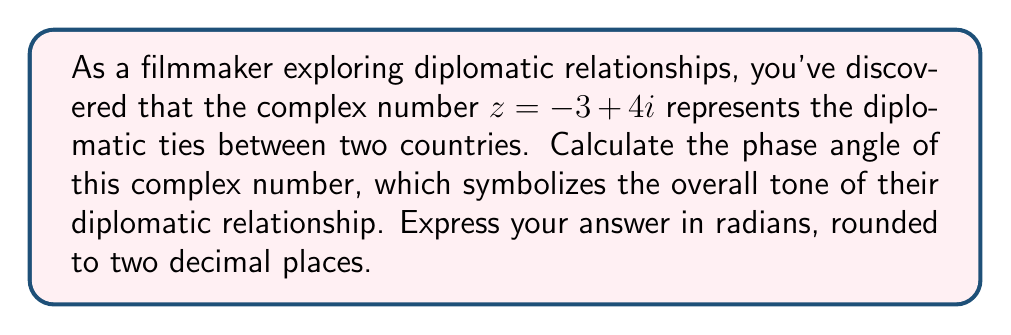What is the answer to this math problem? To calculate the phase angle of a complex number $z = a + bi$, we use the arctangent function:

$$\theta = \arctan\left(\frac{b}{a}\right)$$

However, we need to be careful about which quadrant the complex number is in. In this case, $z = -3 + 4i$ is in the second quadrant (negative real part, positive imaginary part).

For the second quadrant, we need to add $\pi$ to the result of the arctangent function.

Steps:
1. Identify $a$ and $b$: $a = -3$, $b = 4$
2. Calculate $\arctan\left(\frac{b}{a}\right)$:
   $$\arctan\left(\frac{4}{-3}\right) = \arctan(-1.3333...) \approx -0.9273$$
3. Add $\pi$ to account for the second quadrant:
   $$-0.9273 + \pi \approx 2.2143$$

[asy]
import geometry;

size(200);
draw((-4,0)--(4,0),arrow=Arrow(TeXHead));
draw((0,-4)--(0,4),arrow=Arrow(TeXHead));
draw((-3,0)--(-3,4),dashed);
draw((-3,4)--(0,4),dashed);
draw((0,0)--(-3,4),arrow=Arrow(TeXHead));
label("$z = -3 + 4i$", (-3,4), NE);
label("$\theta$", (-1,0.5), N);
label("Re", (4,0), E);
label("Im", (0,4), N);
</asy>

The diagram above illustrates the complex number $z = -3 + 4i$ in the complex plane, with the phase angle $\theta$ marked.
Answer: The phase angle of the complex number $z = -3 + 4i$ is approximately $2.21$ radians. 